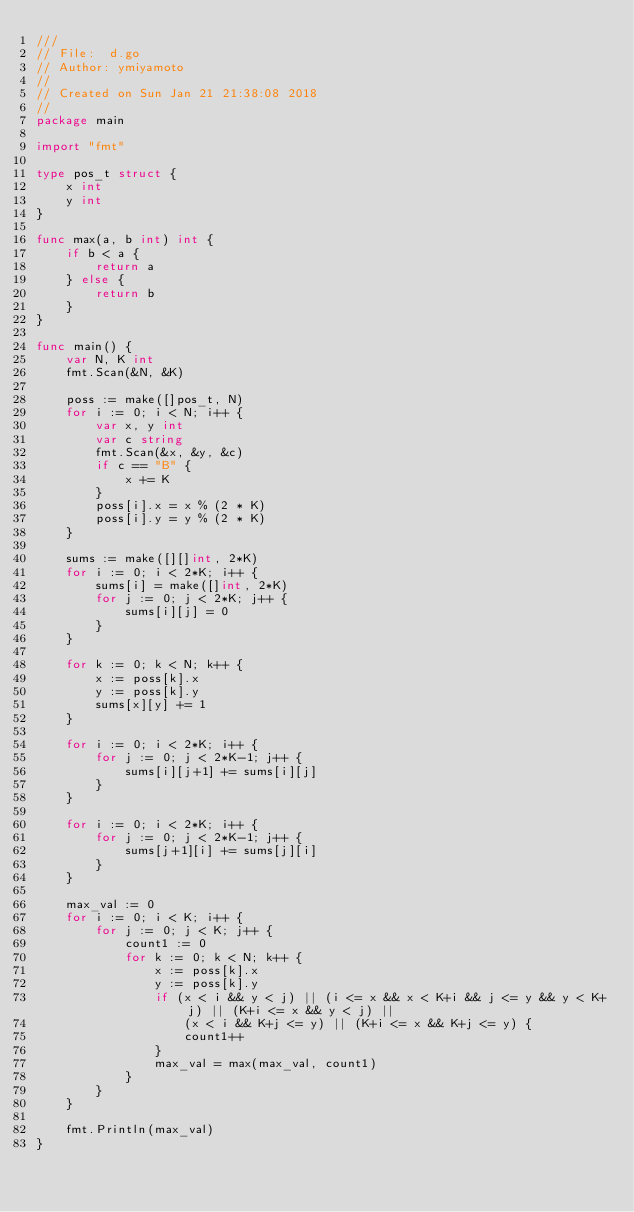<code> <loc_0><loc_0><loc_500><loc_500><_Go_>///
// File:  d.go
// Author: ymiyamoto
//
// Created on Sun Jan 21 21:38:08 2018
//
package main

import "fmt"

type pos_t struct {
	x int
	y int
}

func max(a, b int) int {
	if b < a {
		return a
	} else {
		return b
	}
}

func main() {
	var N, K int
	fmt.Scan(&N, &K)

	poss := make([]pos_t, N)
	for i := 0; i < N; i++ {
		var x, y int
		var c string
		fmt.Scan(&x, &y, &c)
		if c == "B" {
			x += K
		}
		poss[i].x = x % (2 * K)
		poss[i].y = y % (2 * K)
	}

	sums := make([][]int, 2*K)
	for i := 0; i < 2*K; i++ {
		sums[i] = make([]int, 2*K)
		for j := 0; j < 2*K; j++ {
			sums[i][j] = 0
		}
	}

	for k := 0; k < N; k++ {
		x := poss[k].x
		y := poss[k].y
		sums[x][y] += 1
	}

	for i := 0; i < 2*K; i++ {
		for j := 0; j < 2*K-1; j++ {
			sums[i][j+1] += sums[i][j]
		}
	}

	for i := 0; i < 2*K; i++ {
		for j := 0; j < 2*K-1; j++ {
			sums[j+1][i] += sums[j][i]
		}
	}

	max_val := 0
	for i := 0; i < K; i++ {
		for j := 0; j < K; j++ {
			count1 := 0
			for k := 0; k < N; k++ {
				x := poss[k].x
				y := poss[k].y
				if (x < i && y < j) || (i <= x && x < K+i && j <= y && y < K+j) || (K+i <= x && y < j) ||
					(x < i && K+j <= y) || (K+i <= x && K+j <= y) {
					count1++
				}
				max_val = max(max_val, count1)
			}
		}
	}

	fmt.Println(max_val)
}
</code> 